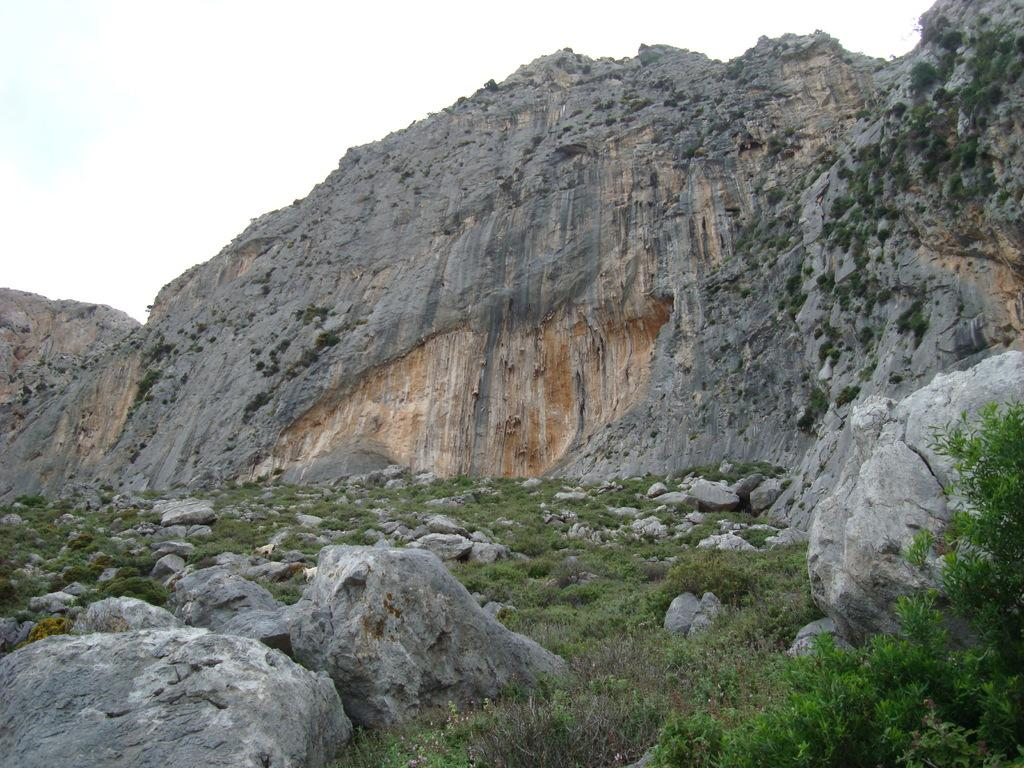What type of natural elements can be seen in the image? There are rocks, stones, and grass visible in the image. What type of geographical feature is present in the image? There is a mountain in the image. What is visible in the sky in the image? The sky is visible in the image. How many leaves are on the spy's hat in the image? There are no leaves or spies present in the image; it features rocks, stones, grass, a mountain, and the sky. 